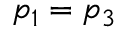<formula> <loc_0><loc_0><loc_500><loc_500>p _ { 1 } = p _ { 3 }</formula> 